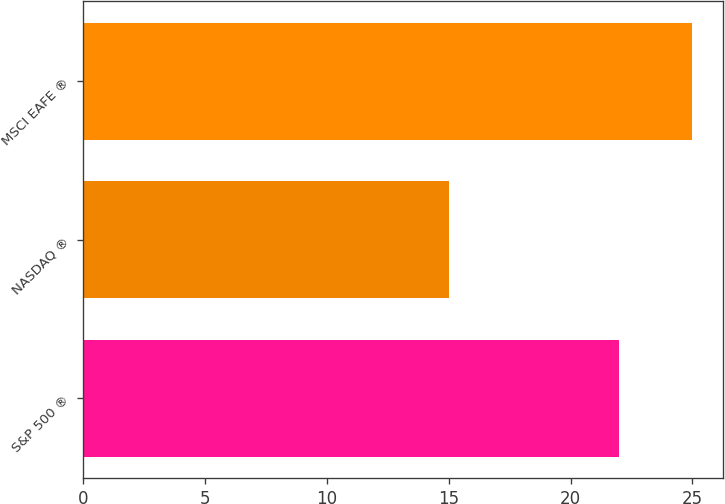Convert chart. <chart><loc_0><loc_0><loc_500><loc_500><bar_chart><fcel>S&P 500 ®<fcel>NASDAQ ®<fcel>MSCI EAFE ®<nl><fcel>22<fcel>15<fcel>25<nl></chart> 